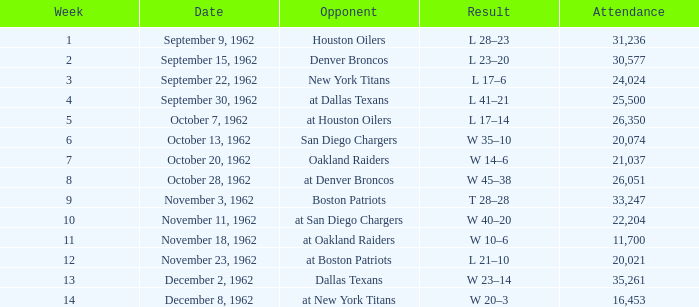Which week had an attendance lower than 22,204 on december 8, 1962? 14.0. 